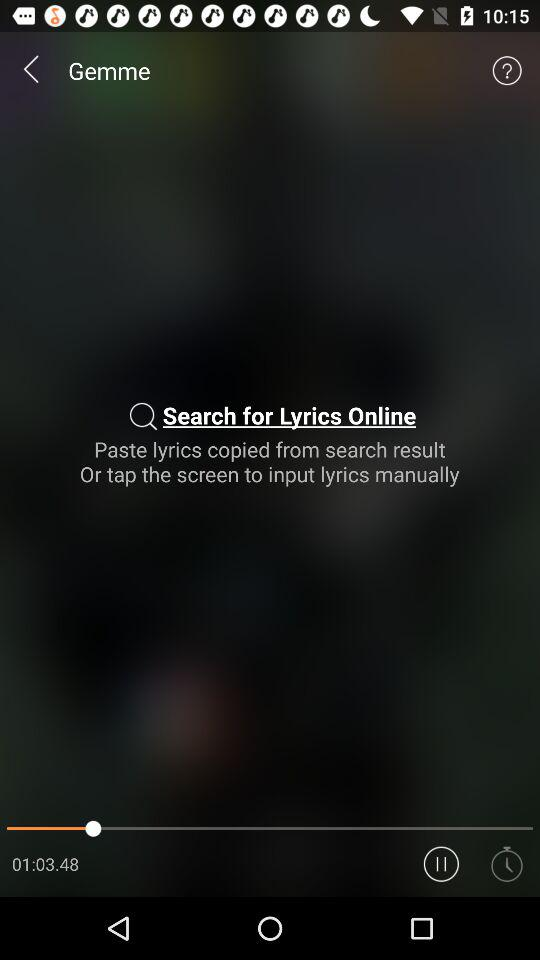What is the mentioned duration? The mentioned duration is 1 hour 3 minutes 48 seconds. 